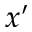Convert formula to latex. <formula><loc_0><loc_0><loc_500><loc_500>x ^ { \prime }</formula> 